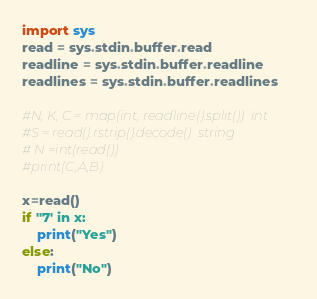Convert code to text. <code><loc_0><loc_0><loc_500><loc_500><_Python_>import sys
read = sys.stdin.buffer.read
readline = sys.stdin.buffer.readline
readlines = sys.stdin.buffer.readlines

#N, K, C = map(int, readline().split())  int
#S = read().rstrip().decode()  string
# N =int(read())
#print(C,A,B)

x=read()
if ''7' in x:
	print("Yes")
else:
	print("No")</code> 